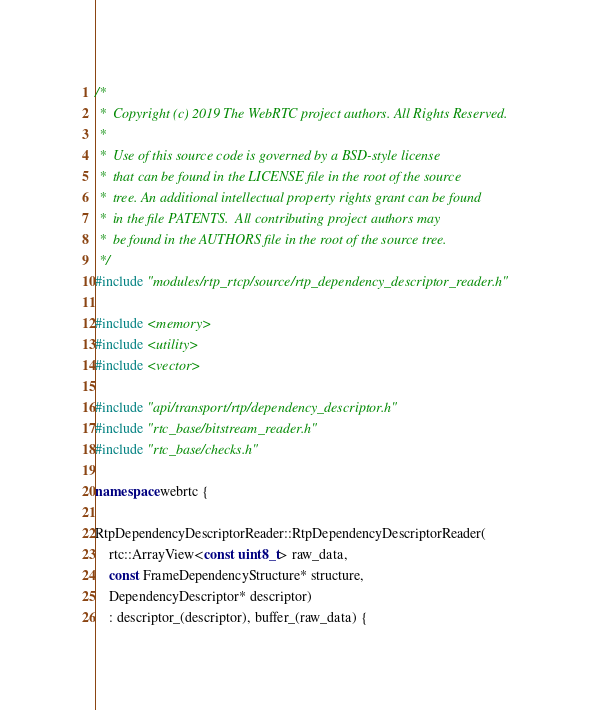Convert code to text. <code><loc_0><loc_0><loc_500><loc_500><_C++_>/*
 *  Copyright (c) 2019 The WebRTC project authors. All Rights Reserved.
 *
 *  Use of this source code is governed by a BSD-style license
 *  that can be found in the LICENSE file in the root of the source
 *  tree. An additional intellectual property rights grant can be found
 *  in the file PATENTS.  All contributing project authors may
 *  be found in the AUTHORS file in the root of the source tree.
 */
#include "modules/rtp_rtcp/source/rtp_dependency_descriptor_reader.h"

#include <memory>
#include <utility>
#include <vector>

#include "api/transport/rtp/dependency_descriptor.h"
#include "rtc_base/bitstream_reader.h"
#include "rtc_base/checks.h"

namespace webrtc {

RtpDependencyDescriptorReader::RtpDependencyDescriptorReader(
    rtc::ArrayView<const uint8_t> raw_data,
    const FrameDependencyStructure* structure,
    DependencyDescriptor* descriptor)
    : descriptor_(descriptor), buffer_(raw_data) {</code> 